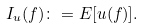<formula> <loc_0><loc_0><loc_500><loc_500>I _ { u } ( f ) \colon = E [ u ( f ) ] .</formula> 